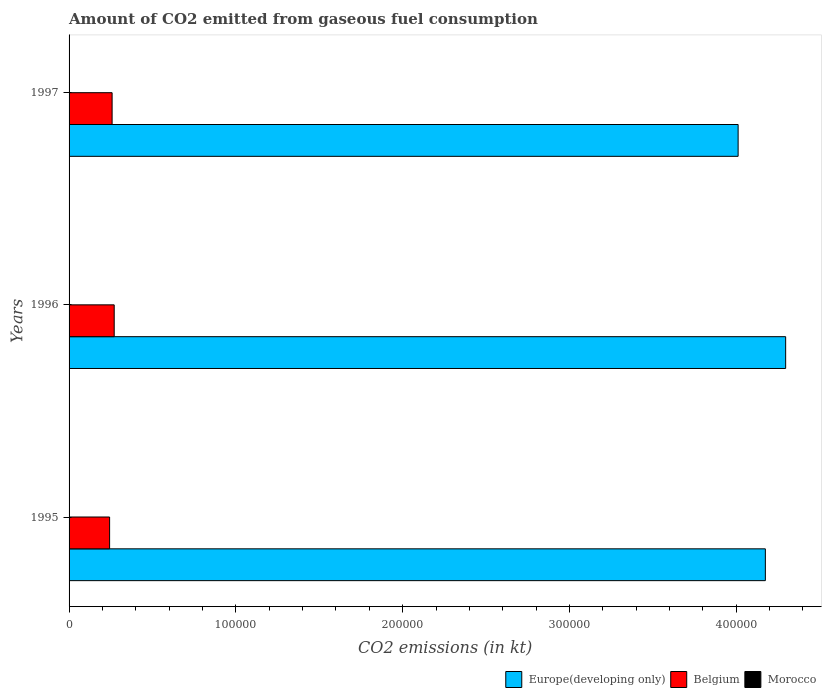Are the number of bars per tick equal to the number of legend labels?
Make the answer very short. Yes. How many bars are there on the 1st tick from the bottom?
Ensure brevity in your answer.  3. What is the amount of CO2 emitted in Morocco in 1997?
Your response must be concise. 66.01. Across all years, what is the maximum amount of CO2 emitted in Morocco?
Ensure brevity in your answer.  66.01. Across all years, what is the minimum amount of CO2 emitted in Europe(developing only)?
Make the answer very short. 4.01e+05. In which year was the amount of CO2 emitted in Belgium minimum?
Make the answer very short. 1995. What is the total amount of CO2 emitted in Europe(developing only) in the graph?
Your answer should be very brief. 1.25e+06. What is the difference between the amount of CO2 emitted in Morocco in 1996 and that in 1997?
Keep it short and to the point. -33. What is the difference between the amount of CO2 emitted in Europe(developing only) in 1996 and the amount of CO2 emitted in Belgium in 1997?
Make the answer very short. 4.04e+05. What is the average amount of CO2 emitted in Europe(developing only) per year?
Offer a terse response. 4.16e+05. In the year 1997, what is the difference between the amount of CO2 emitted in Morocco and amount of CO2 emitted in Belgium?
Your response must be concise. -2.57e+04. What is the ratio of the amount of CO2 emitted in Europe(developing only) in 1996 to that in 1997?
Offer a terse response. 1.07. Is the amount of CO2 emitted in Morocco in 1995 less than that in 1996?
Your answer should be compact. Yes. What is the difference between the highest and the second highest amount of CO2 emitted in Europe(developing only)?
Your answer should be very brief. 1.22e+04. What is the difference between the highest and the lowest amount of CO2 emitted in Europe(developing only)?
Ensure brevity in your answer.  2.85e+04. In how many years, is the amount of CO2 emitted in Belgium greater than the average amount of CO2 emitted in Belgium taken over all years?
Provide a succinct answer. 2. What does the 1st bar from the top in 1997 represents?
Your response must be concise. Morocco. How many bars are there?
Provide a succinct answer. 9. Are all the bars in the graph horizontal?
Your answer should be compact. Yes. How many years are there in the graph?
Provide a short and direct response. 3. How many legend labels are there?
Your answer should be very brief. 3. What is the title of the graph?
Give a very brief answer. Amount of CO2 emitted from gaseous fuel consumption. What is the label or title of the X-axis?
Your response must be concise. CO2 emissions (in kt). What is the label or title of the Y-axis?
Give a very brief answer. Years. What is the CO2 emissions (in kt) in Europe(developing only) in 1995?
Your answer should be compact. 4.17e+05. What is the CO2 emissions (in kt) in Belgium in 1995?
Offer a terse response. 2.43e+04. What is the CO2 emissions (in kt) in Morocco in 1995?
Your answer should be very brief. 25.67. What is the CO2 emissions (in kt) of Europe(developing only) in 1996?
Make the answer very short. 4.30e+05. What is the CO2 emissions (in kt) in Belgium in 1996?
Provide a short and direct response. 2.71e+04. What is the CO2 emissions (in kt) in Morocco in 1996?
Your answer should be very brief. 33. What is the CO2 emissions (in kt) in Europe(developing only) in 1997?
Offer a terse response. 4.01e+05. What is the CO2 emissions (in kt) in Belgium in 1997?
Provide a succinct answer. 2.58e+04. What is the CO2 emissions (in kt) in Morocco in 1997?
Offer a terse response. 66.01. Across all years, what is the maximum CO2 emissions (in kt) in Europe(developing only)?
Your answer should be very brief. 4.30e+05. Across all years, what is the maximum CO2 emissions (in kt) in Belgium?
Offer a very short reply. 2.71e+04. Across all years, what is the maximum CO2 emissions (in kt) of Morocco?
Make the answer very short. 66.01. Across all years, what is the minimum CO2 emissions (in kt) of Europe(developing only)?
Your response must be concise. 4.01e+05. Across all years, what is the minimum CO2 emissions (in kt) of Belgium?
Offer a terse response. 2.43e+04. Across all years, what is the minimum CO2 emissions (in kt) of Morocco?
Keep it short and to the point. 25.67. What is the total CO2 emissions (in kt) in Europe(developing only) in the graph?
Your answer should be compact. 1.25e+06. What is the total CO2 emissions (in kt) of Belgium in the graph?
Make the answer very short. 7.72e+04. What is the total CO2 emissions (in kt) of Morocco in the graph?
Offer a very short reply. 124.68. What is the difference between the CO2 emissions (in kt) of Europe(developing only) in 1995 and that in 1996?
Your answer should be very brief. -1.22e+04. What is the difference between the CO2 emissions (in kt) in Belgium in 1995 and that in 1996?
Ensure brevity in your answer.  -2761.25. What is the difference between the CO2 emissions (in kt) of Morocco in 1995 and that in 1996?
Offer a very short reply. -7.33. What is the difference between the CO2 emissions (in kt) of Europe(developing only) in 1995 and that in 1997?
Your response must be concise. 1.63e+04. What is the difference between the CO2 emissions (in kt) of Belgium in 1995 and that in 1997?
Make the answer very short. -1499.8. What is the difference between the CO2 emissions (in kt) in Morocco in 1995 and that in 1997?
Provide a short and direct response. -40.34. What is the difference between the CO2 emissions (in kt) of Europe(developing only) in 1996 and that in 1997?
Ensure brevity in your answer.  2.85e+04. What is the difference between the CO2 emissions (in kt) of Belgium in 1996 and that in 1997?
Your answer should be compact. 1261.45. What is the difference between the CO2 emissions (in kt) in Morocco in 1996 and that in 1997?
Offer a terse response. -33. What is the difference between the CO2 emissions (in kt) of Europe(developing only) in 1995 and the CO2 emissions (in kt) of Belgium in 1996?
Provide a short and direct response. 3.90e+05. What is the difference between the CO2 emissions (in kt) in Europe(developing only) in 1995 and the CO2 emissions (in kt) in Morocco in 1996?
Give a very brief answer. 4.17e+05. What is the difference between the CO2 emissions (in kt) in Belgium in 1995 and the CO2 emissions (in kt) in Morocco in 1996?
Your answer should be very brief. 2.43e+04. What is the difference between the CO2 emissions (in kt) of Europe(developing only) in 1995 and the CO2 emissions (in kt) of Belgium in 1997?
Your response must be concise. 3.92e+05. What is the difference between the CO2 emissions (in kt) in Europe(developing only) in 1995 and the CO2 emissions (in kt) in Morocco in 1997?
Offer a terse response. 4.17e+05. What is the difference between the CO2 emissions (in kt) of Belgium in 1995 and the CO2 emissions (in kt) of Morocco in 1997?
Offer a terse response. 2.42e+04. What is the difference between the CO2 emissions (in kt) of Europe(developing only) in 1996 and the CO2 emissions (in kt) of Belgium in 1997?
Make the answer very short. 4.04e+05. What is the difference between the CO2 emissions (in kt) in Europe(developing only) in 1996 and the CO2 emissions (in kt) in Morocco in 1997?
Give a very brief answer. 4.30e+05. What is the difference between the CO2 emissions (in kt) of Belgium in 1996 and the CO2 emissions (in kt) of Morocco in 1997?
Your answer should be very brief. 2.70e+04. What is the average CO2 emissions (in kt) of Europe(developing only) per year?
Offer a terse response. 4.16e+05. What is the average CO2 emissions (in kt) of Belgium per year?
Provide a succinct answer. 2.57e+04. What is the average CO2 emissions (in kt) of Morocco per year?
Your answer should be very brief. 41.56. In the year 1995, what is the difference between the CO2 emissions (in kt) in Europe(developing only) and CO2 emissions (in kt) in Belgium?
Your answer should be very brief. 3.93e+05. In the year 1995, what is the difference between the CO2 emissions (in kt) of Europe(developing only) and CO2 emissions (in kt) of Morocco?
Offer a very short reply. 4.17e+05. In the year 1995, what is the difference between the CO2 emissions (in kt) of Belgium and CO2 emissions (in kt) of Morocco?
Your answer should be compact. 2.43e+04. In the year 1996, what is the difference between the CO2 emissions (in kt) in Europe(developing only) and CO2 emissions (in kt) in Belgium?
Your answer should be compact. 4.03e+05. In the year 1996, what is the difference between the CO2 emissions (in kt) in Europe(developing only) and CO2 emissions (in kt) in Morocco?
Make the answer very short. 4.30e+05. In the year 1996, what is the difference between the CO2 emissions (in kt) in Belgium and CO2 emissions (in kt) in Morocco?
Provide a short and direct response. 2.70e+04. In the year 1997, what is the difference between the CO2 emissions (in kt) of Europe(developing only) and CO2 emissions (in kt) of Belgium?
Ensure brevity in your answer.  3.75e+05. In the year 1997, what is the difference between the CO2 emissions (in kt) in Europe(developing only) and CO2 emissions (in kt) in Morocco?
Make the answer very short. 4.01e+05. In the year 1997, what is the difference between the CO2 emissions (in kt) in Belgium and CO2 emissions (in kt) in Morocco?
Keep it short and to the point. 2.57e+04. What is the ratio of the CO2 emissions (in kt) of Europe(developing only) in 1995 to that in 1996?
Your answer should be compact. 0.97. What is the ratio of the CO2 emissions (in kt) of Belgium in 1995 to that in 1996?
Your answer should be very brief. 0.9. What is the ratio of the CO2 emissions (in kt) of Europe(developing only) in 1995 to that in 1997?
Keep it short and to the point. 1.04. What is the ratio of the CO2 emissions (in kt) in Belgium in 1995 to that in 1997?
Your response must be concise. 0.94. What is the ratio of the CO2 emissions (in kt) in Morocco in 1995 to that in 1997?
Provide a short and direct response. 0.39. What is the ratio of the CO2 emissions (in kt) of Europe(developing only) in 1996 to that in 1997?
Offer a terse response. 1.07. What is the ratio of the CO2 emissions (in kt) in Belgium in 1996 to that in 1997?
Give a very brief answer. 1.05. What is the ratio of the CO2 emissions (in kt) of Morocco in 1996 to that in 1997?
Your response must be concise. 0.5. What is the difference between the highest and the second highest CO2 emissions (in kt) in Europe(developing only)?
Ensure brevity in your answer.  1.22e+04. What is the difference between the highest and the second highest CO2 emissions (in kt) of Belgium?
Your response must be concise. 1261.45. What is the difference between the highest and the second highest CO2 emissions (in kt) in Morocco?
Make the answer very short. 33. What is the difference between the highest and the lowest CO2 emissions (in kt) of Europe(developing only)?
Offer a very short reply. 2.85e+04. What is the difference between the highest and the lowest CO2 emissions (in kt) of Belgium?
Your answer should be compact. 2761.25. What is the difference between the highest and the lowest CO2 emissions (in kt) in Morocco?
Make the answer very short. 40.34. 